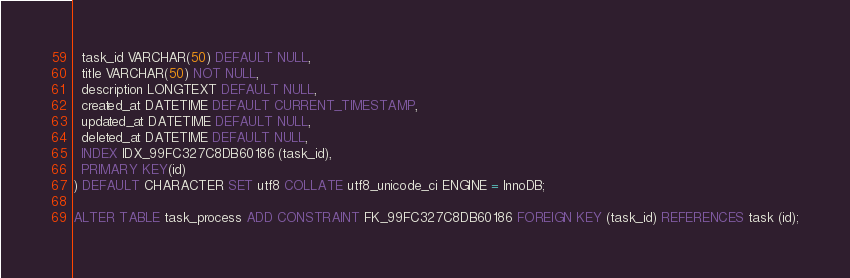<code> <loc_0><loc_0><loc_500><loc_500><_SQL_>  task_id VARCHAR(50) DEFAULT NULL,
  title VARCHAR(50) NOT NULL,
  description LONGTEXT DEFAULT NULL,
  created_at DATETIME DEFAULT CURRENT_TIMESTAMP,
  updated_at DATETIME DEFAULT NULL,
  deleted_at DATETIME DEFAULT NULL,
  INDEX IDX_99FC327C8DB60186 (task_id),
  PRIMARY KEY(id)
) DEFAULT CHARACTER SET utf8 COLLATE utf8_unicode_ci ENGINE = InnoDB;

ALTER TABLE task_process ADD CONSTRAINT FK_99FC327C8DB60186 FOREIGN KEY (task_id) REFERENCES task (id);
</code> 